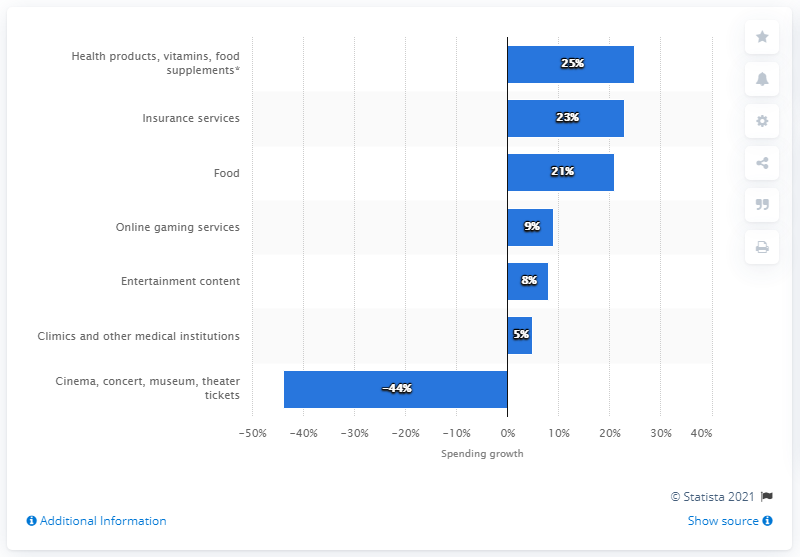Give some essential details in this illustration. Spending on the websites of insurance services in Russia grew by 23% from March 16 to March 22. 